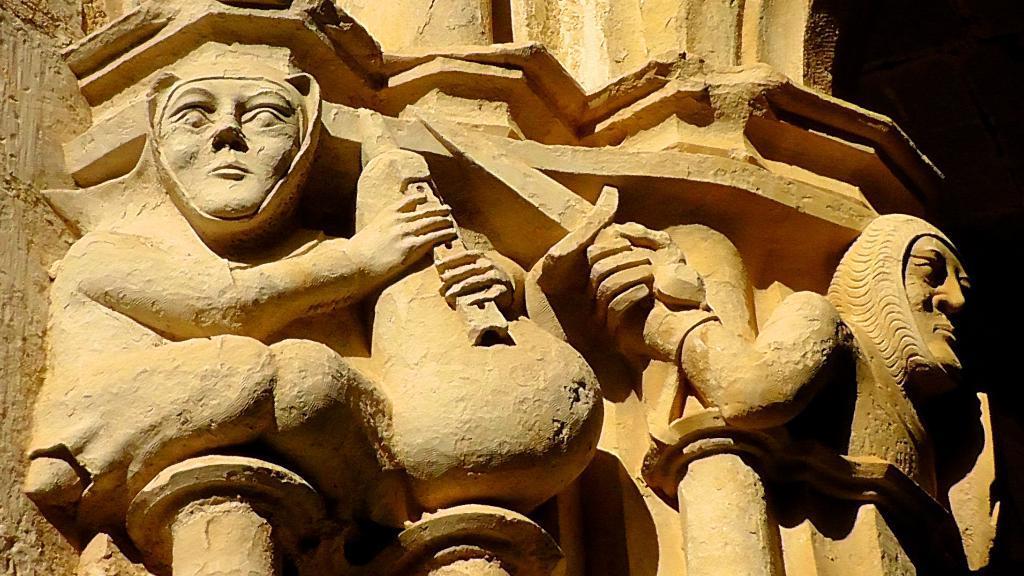In one or two sentences, can you explain what this image depicts? We can see stone carving on the wall. Background it is dark. 